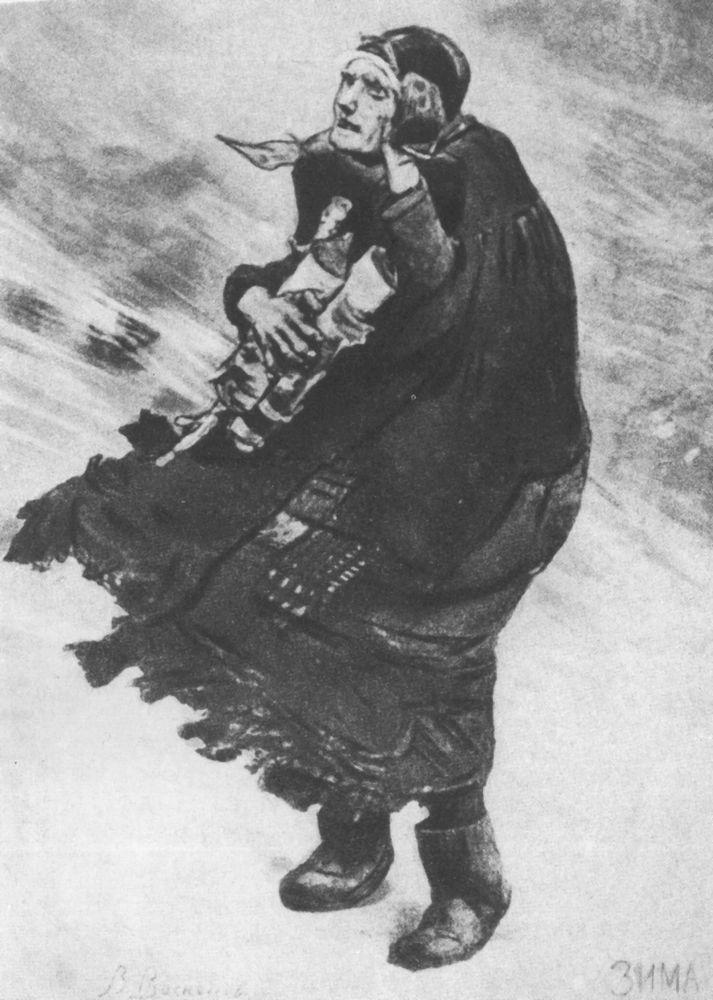What's happening in the scene? This black and white art image captures a poignant moment of determination and care between a woman and a child. The woman, wearing a long dress and a headscarf, carries the child securely on her back as they brave harsh weather conditions. The child's hat and wrapped limbs suggest a measure taken to protect them from the cold. The artwork employs an impressionistic style, focusing on a broader emotional experience rather than intricate details. It belongs to the realism genre, accurately reflecting a potentially historical and everyday scene. The monochromatic color scheme enhances a timeless and universal message, emphasizing the enduring and protective nature of the mother-child bond. The imagery powerfully conveys the simplicity, resilience, and depth found in such moments. 